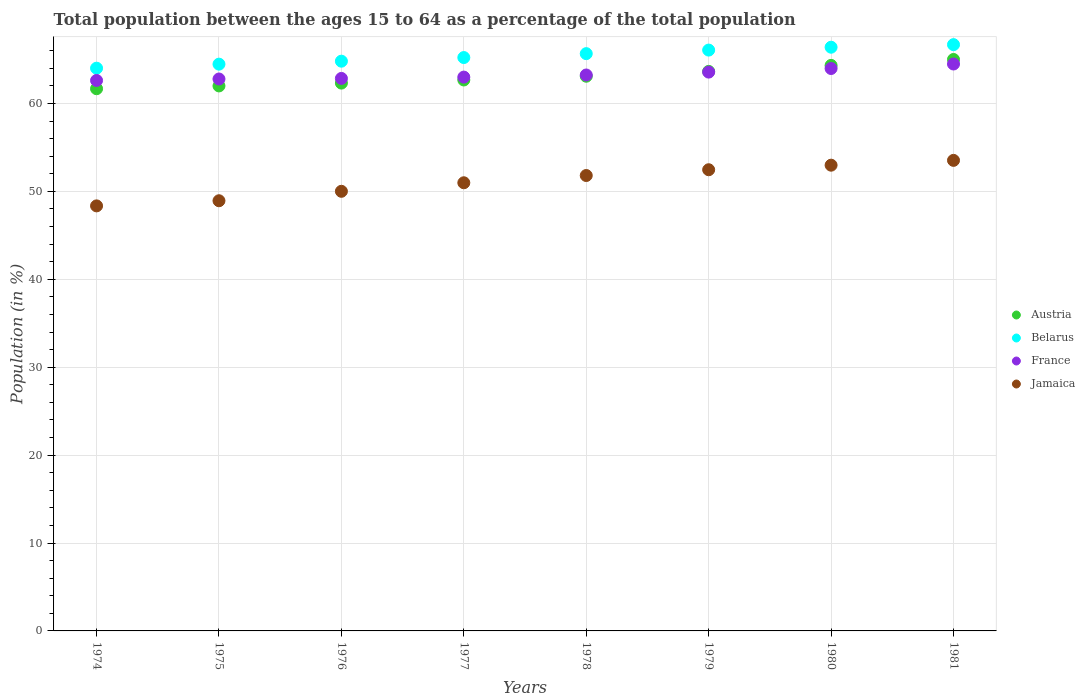How many different coloured dotlines are there?
Provide a short and direct response. 4. What is the percentage of the population ages 15 to 64 in France in 1981?
Ensure brevity in your answer.  64.49. Across all years, what is the maximum percentage of the population ages 15 to 64 in Jamaica?
Offer a very short reply. 53.53. Across all years, what is the minimum percentage of the population ages 15 to 64 in Austria?
Offer a terse response. 61.68. In which year was the percentage of the population ages 15 to 64 in Belarus minimum?
Provide a succinct answer. 1974. What is the total percentage of the population ages 15 to 64 in Jamaica in the graph?
Your response must be concise. 409.06. What is the difference between the percentage of the population ages 15 to 64 in Austria in 1977 and that in 1981?
Provide a succinct answer. -2.33. What is the difference between the percentage of the population ages 15 to 64 in France in 1975 and the percentage of the population ages 15 to 64 in Belarus in 1977?
Ensure brevity in your answer.  -2.44. What is the average percentage of the population ages 15 to 64 in France per year?
Make the answer very short. 63.32. In the year 1977, what is the difference between the percentage of the population ages 15 to 64 in Belarus and percentage of the population ages 15 to 64 in Austria?
Offer a very short reply. 2.55. In how many years, is the percentage of the population ages 15 to 64 in France greater than 8?
Keep it short and to the point. 8. What is the ratio of the percentage of the population ages 15 to 64 in France in 1976 to that in 1979?
Make the answer very short. 0.99. What is the difference between the highest and the second highest percentage of the population ages 15 to 64 in Jamaica?
Offer a terse response. 0.55. What is the difference between the highest and the lowest percentage of the population ages 15 to 64 in Austria?
Offer a terse response. 3.33. Is the sum of the percentage of the population ages 15 to 64 in Belarus in 1979 and 1981 greater than the maximum percentage of the population ages 15 to 64 in Austria across all years?
Provide a succinct answer. Yes. Is it the case that in every year, the sum of the percentage of the population ages 15 to 64 in Jamaica and percentage of the population ages 15 to 64 in France  is greater than the sum of percentage of the population ages 15 to 64 in Belarus and percentage of the population ages 15 to 64 in Austria?
Offer a terse response. No. Is the percentage of the population ages 15 to 64 in Jamaica strictly less than the percentage of the population ages 15 to 64 in Austria over the years?
Make the answer very short. Yes. How many dotlines are there?
Your answer should be very brief. 4. How many years are there in the graph?
Give a very brief answer. 8. What is the difference between two consecutive major ticks on the Y-axis?
Give a very brief answer. 10. Does the graph contain any zero values?
Your answer should be very brief. No. Does the graph contain grids?
Provide a succinct answer. Yes. Where does the legend appear in the graph?
Your response must be concise. Center right. What is the title of the graph?
Ensure brevity in your answer.  Total population between the ages 15 to 64 as a percentage of the total population. Does "Azerbaijan" appear as one of the legend labels in the graph?
Your answer should be very brief. No. What is the Population (in %) of Austria in 1974?
Offer a terse response. 61.68. What is the Population (in %) of Belarus in 1974?
Make the answer very short. 64.01. What is the Population (in %) of France in 1974?
Provide a short and direct response. 62.62. What is the Population (in %) of Jamaica in 1974?
Keep it short and to the point. 48.35. What is the Population (in %) of Austria in 1975?
Your response must be concise. 62. What is the Population (in %) of Belarus in 1975?
Your answer should be compact. 64.47. What is the Population (in %) of France in 1975?
Provide a short and direct response. 62.79. What is the Population (in %) of Jamaica in 1975?
Make the answer very short. 48.94. What is the Population (in %) in Austria in 1976?
Your answer should be very brief. 62.32. What is the Population (in %) of Belarus in 1976?
Offer a very short reply. 64.81. What is the Population (in %) of France in 1976?
Ensure brevity in your answer.  62.85. What is the Population (in %) in Jamaica in 1976?
Your response must be concise. 50.01. What is the Population (in %) of Austria in 1977?
Keep it short and to the point. 62.67. What is the Population (in %) in Belarus in 1977?
Keep it short and to the point. 65.23. What is the Population (in %) of France in 1977?
Provide a short and direct response. 63. What is the Population (in %) in Jamaica in 1977?
Ensure brevity in your answer.  50.98. What is the Population (in %) in Austria in 1978?
Offer a very short reply. 63.1. What is the Population (in %) of Belarus in 1978?
Your answer should be compact. 65.67. What is the Population (in %) in France in 1978?
Offer a terse response. 63.24. What is the Population (in %) in Jamaica in 1978?
Ensure brevity in your answer.  51.81. What is the Population (in %) in Austria in 1979?
Provide a short and direct response. 63.65. What is the Population (in %) in Belarus in 1979?
Offer a terse response. 66.07. What is the Population (in %) of France in 1979?
Offer a very short reply. 63.57. What is the Population (in %) in Jamaica in 1979?
Make the answer very short. 52.46. What is the Population (in %) of Austria in 1980?
Your answer should be very brief. 64.33. What is the Population (in %) of Belarus in 1980?
Your answer should be very brief. 66.4. What is the Population (in %) in France in 1980?
Ensure brevity in your answer.  63.98. What is the Population (in %) of Jamaica in 1980?
Make the answer very short. 52.98. What is the Population (in %) of Austria in 1981?
Keep it short and to the point. 65.01. What is the Population (in %) in Belarus in 1981?
Keep it short and to the point. 66.69. What is the Population (in %) in France in 1981?
Keep it short and to the point. 64.49. What is the Population (in %) in Jamaica in 1981?
Keep it short and to the point. 53.53. Across all years, what is the maximum Population (in %) of Austria?
Ensure brevity in your answer.  65.01. Across all years, what is the maximum Population (in %) of Belarus?
Your answer should be very brief. 66.69. Across all years, what is the maximum Population (in %) of France?
Offer a terse response. 64.49. Across all years, what is the maximum Population (in %) in Jamaica?
Provide a succinct answer. 53.53. Across all years, what is the minimum Population (in %) in Austria?
Ensure brevity in your answer.  61.68. Across all years, what is the minimum Population (in %) of Belarus?
Keep it short and to the point. 64.01. Across all years, what is the minimum Population (in %) of France?
Your answer should be compact. 62.62. Across all years, what is the minimum Population (in %) of Jamaica?
Make the answer very short. 48.35. What is the total Population (in %) of Austria in the graph?
Provide a short and direct response. 504.76. What is the total Population (in %) of Belarus in the graph?
Provide a short and direct response. 523.36. What is the total Population (in %) in France in the graph?
Give a very brief answer. 506.54. What is the total Population (in %) of Jamaica in the graph?
Your response must be concise. 409.06. What is the difference between the Population (in %) of Austria in 1974 and that in 1975?
Ensure brevity in your answer.  -0.32. What is the difference between the Population (in %) in Belarus in 1974 and that in 1975?
Offer a very short reply. -0.46. What is the difference between the Population (in %) in France in 1974 and that in 1975?
Offer a very short reply. -0.17. What is the difference between the Population (in %) in Jamaica in 1974 and that in 1975?
Offer a terse response. -0.58. What is the difference between the Population (in %) in Austria in 1974 and that in 1976?
Provide a succinct answer. -0.64. What is the difference between the Population (in %) of Belarus in 1974 and that in 1976?
Provide a short and direct response. -0.8. What is the difference between the Population (in %) of France in 1974 and that in 1976?
Give a very brief answer. -0.23. What is the difference between the Population (in %) in Jamaica in 1974 and that in 1976?
Your response must be concise. -1.66. What is the difference between the Population (in %) of Austria in 1974 and that in 1977?
Give a very brief answer. -0.99. What is the difference between the Population (in %) of Belarus in 1974 and that in 1977?
Make the answer very short. -1.21. What is the difference between the Population (in %) of France in 1974 and that in 1977?
Make the answer very short. -0.38. What is the difference between the Population (in %) in Jamaica in 1974 and that in 1977?
Provide a succinct answer. -2.63. What is the difference between the Population (in %) of Austria in 1974 and that in 1978?
Offer a very short reply. -1.42. What is the difference between the Population (in %) in Belarus in 1974 and that in 1978?
Offer a terse response. -1.66. What is the difference between the Population (in %) of France in 1974 and that in 1978?
Offer a very short reply. -0.62. What is the difference between the Population (in %) in Jamaica in 1974 and that in 1978?
Make the answer very short. -3.45. What is the difference between the Population (in %) of Austria in 1974 and that in 1979?
Give a very brief answer. -1.97. What is the difference between the Population (in %) in Belarus in 1974 and that in 1979?
Provide a succinct answer. -2.06. What is the difference between the Population (in %) in France in 1974 and that in 1979?
Give a very brief answer. -0.95. What is the difference between the Population (in %) of Jamaica in 1974 and that in 1979?
Give a very brief answer. -4.11. What is the difference between the Population (in %) in Austria in 1974 and that in 1980?
Make the answer very short. -2.65. What is the difference between the Population (in %) in Belarus in 1974 and that in 1980?
Offer a very short reply. -2.39. What is the difference between the Population (in %) of France in 1974 and that in 1980?
Provide a short and direct response. -1.36. What is the difference between the Population (in %) in Jamaica in 1974 and that in 1980?
Your response must be concise. -4.63. What is the difference between the Population (in %) of Austria in 1974 and that in 1981?
Offer a very short reply. -3.33. What is the difference between the Population (in %) in Belarus in 1974 and that in 1981?
Ensure brevity in your answer.  -2.68. What is the difference between the Population (in %) of France in 1974 and that in 1981?
Your response must be concise. -1.87. What is the difference between the Population (in %) of Jamaica in 1974 and that in 1981?
Your response must be concise. -5.18. What is the difference between the Population (in %) of Austria in 1975 and that in 1976?
Your response must be concise. -0.32. What is the difference between the Population (in %) of Belarus in 1975 and that in 1976?
Provide a succinct answer. -0.34. What is the difference between the Population (in %) of France in 1975 and that in 1976?
Your answer should be compact. -0.07. What is the difference between the Population (in %) in Jamaica in 1975 and that in 1976?
Your answer should be compact. -1.07. What is the difference between the Population (in %) in Austria in 1975 and that in 1977?
Provide a succinct answer. -0.68. What is the difference between the Population (in %) of Belarus in 1975 and that in 1977?
Ensure brevity in your answer.  -0.75. What is the difference between the Population (in %) in France in 1975 and that in 1977?
Make the answer very short. -0.21. What is the difference between the Population (in %) in Jamaica in 1975 and that in 1977?
Provide a succinct answer. -2.05. What is the difference between the Population (in %) in Austria in 1975 and that in 1978?
Provide a short and direct response. -1.1. What is the difference between the Population (in %) of Belarus in 1975 and that in 1978?
Offer a very short reply. -1.2. What is the difference between the Population (in %) in France in 1975 and that in 1978?
Provide a succinct answer. -0.46. What is the difference between the Population (in %) in Jamaica in 1975 and that in 1978?
Ensure brevity in your answer.  -2.87. What is the difference between the Population (in %) of Austria in 1975 and that in 1979?
Make the answer very short. -1.65. What is the difference between the Population (in %) in Belarus in 1975 and that in 1979?
Your answer should be compact. -1.6. What is the difference between the Population (in %) in France in 1975 and that in 1979?
Your answer should be very brief. -0.78. What is the difference between the Population (in %) in Jamaica in 1975 and that in 1979?
Offer a terse response. -3.53. What is the difference between the Population (in %) in Austria in 1975 and that in 1980?
Provide a short and direct response. -2.33. What is the difference between the Population (in %) of Belarus in 1975 and that in 1980?
Offer a terse response. -1.93. What is the difference between the Population (in %) in France in 1975 and that in 1980?
Provide a short and direct response. -1.19. What is the difference between the Population (in %) of Jamaica in 1975 and that in 1980?
Offer a very short reply. -4.05. What is the difference between the Population (in %) of Austria in 1975 and that in 1981?
Provide a short and direct response. -3.01. What is the difference between the Population (in %) of Belarus in 1975 and that in 1981?
Keep it short and to the point. -2.22. What is the difference between the Population (in %) in France in 1975 and that in 1981?
Your answer should be very brief. -1.7. What is the difference between the Population (in %) in Jamaica in 1975 and that in 1981?
Offer a terse response. -4.59. What is the difference between the Population (in %) of Austria in 1976 and that in 1977?
Offer a terse response. -0.35. What is the difference between the Population (in %) of Belarus in 1976 and that in 1977?
Make the answer very short. -0.41. What is the difference between the Population (in %) of France in 1976 and that in 1977?
Give a very brief answer. -0.15. What is the difference between the Population (in %) of Jamaica in 1976 and that in 1977?
Keep it short and to the point. -0.97. What is the difference between the Population (in %) in Austria in 1976 and that in 1978?
Keep it short and to the point. -0.78. What is the difference between the Population (in %) in Belarus in 1976 and that in 1978?
Give a very brief answer. -0.86. What is the difference between the Population (in %) in France in 1976 and that in 1978?
Offer a terse response. -0.39. What is the difference between the Population (in %) of Jamaica in 1976 and that in 1978?
Offer a terse response. -1.8. What is the difference between the Population (in %) in Austria in 1976 and that in 1979?
Your answer should be compact. -1.33. What is the difference between the Population (in %) in Belarus in 1976 and that in 1979?
Ensure brevity in your answer.  -1.26. What is the difference between the Population (in %) of France in 1976 and that in 1979?
Keep it short and to the point. -0.72. What is the difference between the Population (in %) of Jamaica in 1976 and that in 1979?
Your answer should be compact. -2.45. What is the difference between the Population (in %) in Austria in 1976 and that in 1980?
Offer a terse response. -2.01. What is the difference between the Population (in %) of Belarus in 1976 and that in 1980?
Provide a succinct answer. -1.59. What is the difference between the Population (in %) in France in 1976 and that in 1980?
Keep it short and to the point. -1.13. What is the difference between the Population (in %) in Jamaica in 1976 and that in 1980?
Your answer should be compact. -2.97. What is the difference between the Population (in %) of Austria in 1976 and that in 1981?
Make the answer very short. -2.69. What is the difference between the Population (in %) in Belarus in 1976 and that in 1981?
Offer a terse response. -1.88. What is the difference between the Population (in %) in France in 1976 and that in 1981?
Provide a short and direct response. -1.64. What is the difference between the Population (in %) of Jamaica in 1976 and that in 1981?
Your answer should be very brief. -3.52. What is the difference between the Population (in %) of Austria in 1977 and that in 1978?
Provide a succinct answer. -0.43. What is the difference between the Population (in %) in Belarus in 1977 and that in 1978?
Your answer should be compact. -0.44. What is the difference between the Population (in %) in France in 1977 and that in 1978?
Ensure brevity in your answer.  -0.24. What is the difference between the Population (in %) of Jamaica in 1977 and that in 1978?
Make the answer very short. -0.82. What is the difference between the Population (in %) of Austria in 1977 and that in 1979?
Offer a terse response. -0.98. What is the difference between the Population (in %) in Belarus in 1977 and that in 1979?
Provide a short and direct response. -0.85. What is the difference between the Population (in %) in France in 1977 and that in 1979?
Offer a very short reply. -0.57. What is the difference between the Population (in %) of Jamaica in 1977 and that in 1979?
Offer a terse response. -1.48. What is the difference between the Population (in %) of Austria in 1977 and that in 1980?
Provide a short and direct response. -1.66. What is the difference between the Population (in %) in Belarus in 1977 and that in 1980?
Your response must be concise. -1.17. What is the difference between the Population (in %) in France in 1977 and that in 1980?
Offer a very short reply. -0.98. What is the difference between the Population (in %) of Jamaica in 1977 and that in 1980?
Ensure brevity in your answer.  -2. What is the difference between the Population (in %) of Austria in 1977 and that in 1981?
Provide a short and direct response. -2.33. What is the difference between the Population (in %) in Belarus in 1977 and that in 1981?
Make the answer very short. -1.47. What is the difference between the Population (in %) of France in 1977 and that in 1981?
Provide a succinct answer. -1.49. What is the difference between the Population (in %) of Jamaica in 1977 and that in 1981?
Provide a short and direct response. -2.55. What is the difference between the Population (in %) of Austria in 1978 and that in 1979?
Your answer should be compact. -0.55. What is the difference between the Population (in %) of Belarus in 1978 and that in 1979?
Your answer should be compact. -0.4. What is the difference between the Population (in %) of France in 1978 and that in 1979?
Offer a very short reply. -0.33. What is the difference between the Population (in %) in Jamaica in 1978 and that in 1979?
Your answer should be compact. -0.66. What is the difference between the Population (in %) in Austria in 1978 and that in 1980?
Keep it short and to the point. -1.23. What is the difference between the Population (in %) in Belarus in 1978 and that in 1980?
Offer a very short reply. -0.73. What is the difference between the Population (in %) in France in 1978 and that in 1980?
Provide a succinct answer. -0.74. What is the difference between the Population (in %) in Jamaica in 1978 and that in 1980?
Give a very brief answer. -1.18. What is the difference between the Population (in %) in Austria in 1978 and that in 1981?
Give a very brief answer. -1.91. What is the difference between the Population (in %) of Belarus in 1978 and that in 1981?
Make the answer very short. -1.02. What is the difference between the Population (in %) of France in 1978 and that in 1981?
Provide a succinct answer. -1.25. What is the difference between the Population (in %) in Jamaica in 1978 and that in 1981?
Your response must be concise. -1.72. What is the difference between the Population (in %) in Austria in 1979 and that in 1980?
Your answer should be compact. -0.68. What is the difference between the Population (in %) of Belarus in 1979 and that in 1980?
Provide a succinct answer. -0.33. What is the difference between the Population (in %) in France in 1979 and that in 1980?
Ensure brevity in your answer.  -0.41. What is the difference between the Population (in %) in Jamaica in 1979 and that in 1980?
Your response must be concise. -0.52. What is the difference between the Population (in %) in Austria in 1979 and that in 1981?
Your answer should be very brief. -1.36. What is the difference between the Population (in %) of Belarus in 1979 and that in 1981?
Keep it short and to the point. -0.62. What is the difference between the Population (in %) of France in 1979 and that in 1981?
Provide a succinct answer. -0.92. What is the difference between the Population (in %) in Jamaica in 1979 and that in 1981?
Ensure brevity in your answer.  -1.07. What is the difference between the Population (in %) of Austria in 1980 and that in 1981?
Your answer should be very brief. -0.67. What is the difference between the Population (in %) in Belarus in 1980 and that in 1981?
Offer a terse response. -0.29. What is the difference between the Population (in %) in France in 1980 and that in 1981?
Provide a short and direct response. -0.51. What is the difference between the Population (in %) of Jamaica in 1980 and that in 1981?
Ensure brevity in your answer.  -0.55. What is the difference between the Population (in %) of Austria in 1974 and the Population (in %) of Belarus in 1975?
Make the answer very short. -2.79. What is the difference between the Population (in %) in Austria in 1974 and the Population (in %) in France in 1975?
Offer a terse response. -1.11. What is the difference between the Population (in %) in Austria in 1974 and the Population (in %) in Jamaica in 1975?
Ensure brevity in your answer.  12.74. What is the difference between the Population (in %) of Belarus in 1974 and the Population (in %) of France in 1975?
Provide a short and direct response. 1.23. What is the difference between the Population (in %) of Belarus in 1974 and the Population (in %) of Jamaica in 1975?
Make the answer very short. 15.08. What is the difference between the Population (in %) of France in 1974 and the Population (in %) of Jamaica in 1975?
Your answer should be very brief. 13.68. What is the difference between the Population (in %) of Austria in 1974 and the Population (in %) of Belarus in 1976?
Offer a very short reply. -3.13. What is the difference between the Population (in %) in Austria in 1974 and the Population (in %) in France in 1976?
Give a very brief answer. -1.17. What is the difference between the Population (in %) in Austria in 1974 and the Population (in %) in Jamaica in 1976?
Your response must be concise. 11.67. What is the difference between the Population (in %) in Belarus in 1974 and the Population (in %) in France in 1976?
Make the answer very short. 1.16. What is the difference between the Population (in %) of Belarus in 1974 and the Population (in %) of Jamaica in 1976?
Provide a succinct answer. 14. What is the difference between the Population (in %) of France in 1974 and the Population (in %) of Jamaica in 1976?
Give a very brief answer. 12.61. What is the difference between the Population (in %) in Austria in 1974 and the Population (in %) in Belarus in 1977?
Your answer should be very brief. -3.55. What is the difference between the Population (in %) of Austria in 1974 and the Population (in %) of France in 1977?
Give a very brief answer. -1.32. What is the difference between the Population (in %) of Austria in 1974 and the Population (in %) of Jamaica in 1977?
Offer a very short reply. 10.7. What is the difference between the Population (in %) in Belarus in 1974 and the Population (in %) in France in 1977?
Your answer should be very brief. 1.01. What is the difference between the Population (in %) of Belarus in 1974 and the Population (in %) of Jamaica in 1977?
Provide a short and direct response. 13.03. What is the difference between the Population (in %) of France in 1974 and the Population (in %) of Jamaica in 1977?
Give a very brief answer. 11.64. What is the difference between the Population (in %) of Austria in 1974 and the Population (in %) of Belarus in 1978?
Give a very brief answer. -3.99. What is the difference between the Population (in %) in Austria in 1974 and the Population (in %) in France in 1978?
Offer a very short reply. -1.56. What is the difference between the Population (in %) of Austria in 1974 and the Population (in %) of Jamaica in 1978?
Provide a short and direct response. 9.87. What is the difference between the Population (in %) of Belarus in 1974 and the Population (in %) of France in 1978?
Your answer should be very brief. 0.77. What is the difference between the Population (in %) of Belarus in 1974 and the Population (in %) of Jamaica in 1978?
Provide a short and direct response. 12.21. What is the difference between the Population (in %) of France in 1974 and the Population (in %) of Jamaica in 1978?
Your answer should be compact. 10.81. What is the difference between the Population (in %) of Austria in 1974 and the Population (in %) of Belarus in 1979?
Offer a very short reply. -4.4. What is the difference between the Population (in %) of Austria in 1974 and the Population (in %) of France in 1979?
Your answer should be very brief. -1.89. What is the difference between the Population (in %) in Austria in 1974 and the Population (in %) in Jamaica in 1979?
Your response must be concise. 9.22. What is the difference between the Population (in %) of Belarus in 1974 and the Population (in %) of France in 1979?
Provide a short and direct response. 0.45. What is the difference between the Population (in %) in Belarus in 1974 and the Population (in %) in Jamaica in 1979?
Give a very brief answer. 11.55. What is the difference between the Population (in %) in France in 1974 and the Population (in %) in Jamaica in 1979?
Provide a short and direct response. 10.16. What is the difference between the Population (in %) in Austria in 1974 and the Population (in %) in Belarus in 1980?
Your answer should be very brief. -4.72. What is the difference between the Population (in %) of Austria in 1974 and the Population (in %) of France in 1980?
Ensure brevity in your answer.  -2.3. What is the difference between the Population (in %) in Austria in 1974 and the Population (in %) in Jamaica in 1980?
Ensure brevity in your answer.  8.7. What is the difference between the Population (in %) in Belarus in 1974 and the Population (in %) in France in 1980?
Give a very brief answer. 0.04. What is the difference between the Population (in %) in Belarus in 1974 and the Population (in %) in Jamaica in 1980?
Offer a very short reply. 11.03. What is the difference between the Population (in %) of France in 1974 and the Population (in %) of Jamaica in 1980?
Provide a short and direct response. 9.64. What is the difference between the Population (in %) of Austria in 1974 and the Population (in %) of Belarus in 1981?
Your response must be concise. -5.02. What is the difference between the Population (in %) in Austria in 1974 and the Population (in %) in France in 1981?
Give a very brief answer. -2.81. What is the difference between the Population (in %) of Austria in 1974 and the Population (in %) of Jamaica in 1981?
Keep it short and to the point. 8.15. What is the difference between the Population (in %) of Belarus in 1974 and the Population (in %) of France in 1981?
Your answer should be very brief. -0.48. What is the difference between the Population (in %) in Belarus in 1974 and the Population (in %) in Jamaica in 1981?
Your answer should be compact. 10.49. What is the difference between the Population (in %) in France in 1974 and the Population (in %) in Jamaica in 1981?
Keep it short and to the point. 9.09. What is the difference between the Population (in %) of Austria in 1975 and the Population (in %) of Belarus in 1976?
Make the answer very short. -2.81. What is the difference between the Population (in %) of Austria in 1975 and the Population (in %) of France in 1976?
Give a very brief answer. -0.85. What is the difference between the Population (in %) in Austria in 1975 and the Population (in %) in Jamaica in 1976?
Keep it short and to the point. 11.99. What is the difference between the Population (in %) of Belarus in 1975 and the Population (in %) of France in 1976?
Your response must be concise. 1.62. What is the difference between the Population (in %) in Belarus in 1975 and the Population (in %) in Jamaica in 1976?
Ensure brevity in your answer.  14.46. What is the difference between the Population (in %) of France in 1975 and the Population (in %) of Jamaica in 1976?
Your answer should be very brief. 12.78. What is the difference between the Population (in %) in Austria in 1975 and the Population (in %) in Belarus in 1977?
Your response must be concise. -3.23. What is the difference between the Population (in %) of Austria in 1975 and the Population (in %) of France in 1977?
Offer a terse response. -1. What is the difference between the Population (in %) of Austria in 1975 and the Population (in %) of Jamaica in 1977?
Offer a very short reply. 11.02. What is the difference between the Population (in %) in Belarus in 1975 and the Population (in %) in France in 1977?
Offer a very short reply. 1.47. What is the difference between the Population (in %) in Belarus in 1975 and the Population (in %) in Jamaica in 1977?
Provide a succinct answer. 13.49. What is the difference between the Population (in %) of France in 1975 and the Population (in %) of Jamaica in 1977?
Your answer should be very brief. 11.81. What is the difference between the Population (in %) of Austria in 1975 and the Population (in %) of Belarus in 1978?
Give a very brief answer. -3.67. What is the difference between the Population (in %) of Austria in 1975 and the Population (in %) of France in 1978?
Offer a terse response. -1.24. What is the difference between the Population (in %) in Austria in 1975 and the Population (in %) in Jamaica in 1978?
Give a very brief answer. 10.19. What is the difference between the Population (in %) of Belarus in 1975 and the Population (in %) of France in 1978?
Provide a short and direct response. 1.23. What is the difference between the Population (in %) in Belarus in 1975 and the Population (in %) in Jamaica in 1978?
Your answer should be compact. 12.67. What is the difference between the Population (in %) of France in 1975 and the Population (in %) of Jamaica in 1978?
Give a very brief answer. 10.98. What is the difference between the Population (in %) in Austria in 1975 and the Population (in %) in Belarus in 1979?
Offer a very short reply. -4.08. What is the difference between the Population (in %) in Austria in 1975 and the Population (in %) in France in 1979?
Offer a very short reply. -1.57. What is the difference between the Population (in %) of Austria in 1975 and the Population (in %) of Jamaica in 1979?
Keep it short and to the point. 9.53. What is the difference between the Population (in %) in Belarus in 1975 and the Population (in %) in France in 1979?
Offer a terse response. 0.9. What is the difference between the Population (in %) in Belarus in 1975 and the Population (in %) in Jamaica in 1979?
Keep it short and to the point. 12.01. What is the difference between the Population (in %) of France in 1975 and the Population (in %) of Jamaica in 1979?
Give a very brief answer. 10.32. What is the difference between the Population (in %) of Austria in 1975 and the Population (in %) of Belarus in 1980?
Ensure brevity in your answer.  -4.4. What is the difference between the Population (in %) of Austria in 1975 and the Population (in %) of France in 1980?
Ensure brevity in your answer.  -1.98. What is the difference between the Population (in %) of Austria in 1975 and the Population (in %) of Jamaica in 1980?
Keep it short and to the point. 9.02. What is the difference between the Population (in %) in Belarus in 1975 and the Population (in %) in France in 1980?
Your answer should be compact. 0.5. What is the difference between the Population (in %) in Belarus in 1975 and the Population (in %) in Jamaica in 1980?
Make the answer very short. 11.49. What is the difference between the Population (in %) in France in 1975 and the Population (in %) in Jamaica in 1980?
Provide a succinct answer. 9.8. What is the difference between the Population (in %) in Austria in 1975 and the Population (in %) in Belarus in 1981?
Keep it short and to the point. -4.7. What is the difference between the Population (in %) of Austria in 1975 and the Population (in %) of France in 1981?
Provide a short and direct response. -2.49. What is the difference between the Population (in %) in Austria in 1975 and the Population (in %) in Jamaica in 1981?
Your answer should be compact. 8.47. What is the difference between the Population (in %) in Belarus in 1975 and the Population (in %) in France in 1981?
Give a very brief answer. -0.02. What is the difference between the Population (in %) in Belarus in 1975 and the Population (in %) in Jamaica in 1981?
Offer a terse response. 10.95. What is the difference between the Population (in %) in France in 1975 and the Population (in %) in Jamaica in 1981?
Your answer should be very brief. 9.26. What is the difference between the Population (in %) of Austria in 1976 and the Population (in %) of Belarus in 1977?
Keep it short and to the point. -2.91. What is the difference between the Population (in %) of Austria in 1976 and the Population (in %) of France in 1977?
Offer a terse response. -0.68. What is the difference between the Population (in %) in Austria in 1976 and the Population (in %) in Jamaica in 1977?
Your answer should be compact. 11.34. What is the difference between the Population (in %) of Belarus in 1976 and the Population (in %) of France in 1977?
Your response must be concise. 1.81. What is the difference between the Population (in %) of Belarus in 1976 and the Population (in %) of Jamaica in 1977?
Make the answer very short. 13.83. What is the difference between the Population (in %) of France in 1976 and the Population (in %) of Jamaica in 1977?
Give a very brief answer. 11.87. What is the difference between the Population (in %) of Austria in 1976 and the Population (in %) of Belarus in 1978?
Give a very brief answer. -3.35. What is the difference between the Population (in %) in Austria in 1976 and the Population (in %) in France in 1978?
Your answer should be very brief. -0.92. What is the difference between the Population (in %) of Austria in 1976 and the Population (in %) of Jamaica in 1978?
Provide a short and direct response. 10.51. What is the difference between the Population (in %) in Belarus in 1976 and the Population (in %) in France in 1978?
Provide a short and direct response. 1.57. What is the difference between the Population (in %) of Belarus in 1976 and the Population (in %) of Jamaica in 1978?
Give a very brief answer. 13.01. What is the difference between the Population (in %) in France in 1976 and the Population (in %) in Jamaica in 1978?
Make the answer very short. 11.05. What is the difference between the Population (in %) of Austria in 1976 and the Population (in %) of Belarus in 1979?
Provide a short and direct response. -3.76. What is the difference between the Population (in %) in Austria in 1976 and the Population (in %) in France in 1979?
Make the answer very short. -1.25. What is the difference between the Population (in %) in Austria in 1976 and the Population (in %) in Jamaica in 1979?
Give a very brief answer. 9.86. What is the difference between the Population (in %) of Belarus in 1976 and the Population (in %) of France in 1979?
Provide a succinct answer. 1.24. What is the difference between the Population (in %) of Belarus in 1976 and the Population (in %) of Jamaica in 1979?
Offer a very short reply. 12.35. What is the difference between the Population (in %) of France in 1976 and the Population (in %) of Jamaica in 1979?
Give a very brief answer. 10.39. What is the difference between the Population (in %) of Austria in 1976 and the Population (in %) of Belarus in 1980?
Make the answer very short. -4.08. What is the difference between the Population (in %) in Austria in 1976 and the Population (in %) in France in 1980?
Make the answer very short. -1.66. What is the difference between the Population (in %) in Austria in 1976 and the Population (in %) in Jamaica in 1980?
Provide a short and direct response. 9.34. What is the difference between the Population (in %) of Belarus in 1976 and the Population (in %) of France in 1980?
Make the answer very short. 0.83. What is the difference between the Population (in %) in Belarus in 1976 and the Population (in %) in Jamaica in 1980?
Provide a succinct answer. 11.83. What is the difference between the Population (in %) in France in 1976 and the Population (in %) in Jamaica in 1980?
Provide a succinct answer. 9.87. What is the difference between the Population (in %) of Austria in 1976 and the Population (in %) of Belarus in 1981?
Give a very brief answer. -4.38. What is the difference between the Population (in %) of Austria in 1976 and the Population (in %) of France in 1981?
Your response must be concise. -2.17. What is the difference between the Population (in %) in Austria in 1976 and the Population (in %) in Jamaica in 1981?
Provide a succinct answer. 8.79. What is the difference between the Population (in %) in Belarus in 1976 and the Population (in %) in France in 1981?
Offer a very short reply. 0.32. What is the difference between the Population (in %) in Belarus in 1976 and the Population (in %) in Jamaica in 1981?
Ensure brevity in your answer.  11.28. What is the difference between the Population (in %) in France in 1976 and the Population (in %) in Jamaica in 1981?
Make the answer very short. 9.32. What is the difference between the Population (in %) in Austria in 1977 and the Population (in %) in Belarus in 1978?
Provide a short and direct response. -3. What is the difference between the Population (in %) of Austria in 1977 and the Population (in %) of France in 1978?
Keep it short and to the point. -0.57. What is the difference between the Population (in %) of Austria in 1977 and the Population (in %) of Jamaica in 1978?
Give a very brief answer. 10.87. What is the difference between the Population (in %) of Belarus in 1977 and the Population (in %) of France in 1978?
Keep it short and to the point. 1.98. What is the difference between the Population (in %) of Belarus in 1977 and the Population (in %) of Jamaica in 1978?
Your response must be concise. 13.42. What is the difference between the Population (in %) in France in 1977 and the Population (in %) in Jamaica in 1978?
Provide a succinct answer. 11.2. What is the difference between the Population (in %) of Austria in 1977 and the Population (in %) of Belarus in 1979?
Provide a succinct answer. -3.4. What is the difference between the Population (in %) of Austria in 1977 and the Population (in %) of France in 1979?
Give a very brief answer. -0.9. What is the difference between the Population (in %) in Austria in 1977 and the Population (in %) in Jamaica in 1979?
Provide a succinct answer. 10.21. What is the difference between the Population (in %) of Belarus in 1977 and the Population (in %) of France in 1979?
Give a very brief answer. 1.66. What is the difference between the Population (in %) of Belarus in 1977 and the Population (in %) of Jamaica in 1979?
Provide a short and direct response. 12.76. What is the difference between the Population (in %) of France in 1977 and the Population (in %) of Jamaica in 1979?
Offer a very short reply. 10.54. What is the difference between the Population (in %) of Austria in 1977 and the Population (in %) of Belarus in 1980?
Offer a terse response. -3.73. What is the difference between the Population (in %) of Austria in 1977 and the Population (in %) of France in 1980?
Provide a succinct answer. -1.31. What is the difference between the Population (in %) in Austria in 1977 and the Population (in %) in Jamaica in 1980?
Offer a terse response. 9.69. What is the difference between the Population (in %) in Belarus in 1977 and the Population (in %) in France in 1980?
Make the answer very short. 1.25. What is the difference between the Population (in %) in Belarus in 1977 and the Population (in %) in Jamaica in 1980?
Your response must be concise. 12.24. What is the difference between the Population (in %) in France in 1977 and the Population (in %) in Jamaica in 1980?
Your response must be concise. 10.02. What is the difference between the Population (in %) in Austria in 1977 and the Population (in %) in Belarus in 1981?
Make the answer very short. -4.02. What is the difference between the Population (in %) of Austria in 1977 and the Population (in %) of France in 1981?
Make the answer very short. -1.82. What is the difference between the Population (in %) in Austria in 1977 and the Population (in %) in Jamaica in 1981?
Ensure brevity in your answer.  9.14. What is the difference between the Population (in %) of Belarus in 1977 and the Population (in %) of France in 1981?
Your response must be concise. 0.74. What is the difference between the Population (in %) of Belarus in 1977 and the Population (in %) of Jamaica in 1981?
Provide a succinct answer. 11.7. What is the difference between the Population (in %) in France in 1977 and the Population (in %) in Jamaica in 1981?
Provide a succinct answer. 9.47. What is the difference between the Population (in %) in Austria in 1978 and the Population (in %) in Belarus in 1979?
Keep it short and to the point. -2.97. What is the difference between the Population (in %) in Austria in 1978 and the Population (in %) in France in 1979?
Your answer should be very brief. -0.47. What is the difference between the Population (in %) of Austria in 1978 and the Population (in %) of Jamaica in 1979?
Provide a succinct answer. 10.64. What is the difference between the Population (in %) of Belarus in 1978 and the Population (in %) of France in 1979?
Offer a very short reply. 2.1. What is the difference between the Population (in %) of Belarus in 1978 and the Population (in %) of Jamaica in 1979?
Your answer should be very brief. 13.21. What is the difference between the Population (in %) in France in 1978 and the Population (in %) in Jamaica in 1979?
Offer a very short reply. 10.78. What is the difference between the Population (in %) of Austria in 1978 and the Population (in %) of Belarus in 1980?
Make the answer very short. -3.3. What is the difference between the Population (in %) of Austria in 1978 and the Population (in %) of France in 1980?
Keep it short and to the point. -0.88. What is the difference between the Population (in %) in Austria in 1978 and the Population (in %) in Jamaica in 1980?
Your answer should be very brief. 10.12. What is the difference between the Population (in %) of Belarus in 1978 and the Population (in %) of France in 1980?
Your response must be concise. 1.69. What is the difference between the Population (in %) in Belarus in 1978 and the Population (in %) in Jamaica in 1980?
Keep it short and to the point. 12.69. What is the difference between the Population (in %) in France in 1978 and the Population (in %) in Jamaica in 1980?
Your answer should be very brief. 10.26. What is the difference between the Population (in %) of Austria in 1978 and the Population (in %) of Belarus in 1981?
Offer a very short reply. -3.59. What is the difference between the Population (in %) of Austria in 1978 and the Population (in %) of France in 1981?
Ensure brevity in your answer.  -1.39. What is the difference between the Population (in %) of Austria in 1978 and the Population (in %) of Jamaica in 1981?
Keep it short and to the point. 9.57. What is the difference between the Population (in %) of Belarus in 1978 and the Population (in %) of France in 1981?
Give a very brief answer. 1.18. What is the difference between the Population (in %) of Belarus in 1978 and the Population (in %) of Jamaica in 1981?
Offer a very short reply. 12.14. What is the difference between the Population (in %) in France in 1978 and the Population (in %) in Jamaica in 1981?
Your answer should be very brief. 9.71. What is the difference between the Population (in %) of Austria in 1979 and the Population (in %) of Belarus in 1980?
Keep it short and to the point. -2.75. What is the difference between the Population (in %) of Austria in 1979 and the Population (in %) of France in 1980?
Make the answer very short. -0.33. What is the difference between the Population (in %) in Austria in 1979 and the Population (in %) in Jamaica in 1980?
Make the answer very short. 10.67. What is the difference between the Population (in %) of Belarus in 1979 and the Population (in %) of France in 1980?
Keep it short and to the point. 2.1. What is the difference between the Population (in %) in Belarus in 1979 and the Population (in %) in Jamaica in 1980?
Your answer should be compact. 13.09. What is the difference between the Population (in %) of France in 1979 and the Population (in %) of Jamaica in 1980?
Keep it short and to the point. 10.59. What is the difference between the Population (in %) of Austria in 1979 and the Population (in %) of Belarus in 1981?
Offer a terse response. -3.04. What is the difference between the Population (in %) in Austria in 1979 and the Population (in %) in France in 1981?
Offer a terse response. -0.84. What is the difference between the Population (in %) in Austria in 1979 and the Population (in %) in Jamaica in 1981?
Offer a terse response. 10.12. What is the difference between the Population (in %) of Belarus in 1979 and the Population (in %) of France in 1981?
Offer a terse response. 1.58. What is the difference between the Population (in %) in Belarus in 1979 and the Population (in %) in Jamaica in 1981?
Offer a very short reply. 12.55. What is the difference between the Population (in %) in France in 1979 and the Population (in %) in Jamaica in 1981?
Your answer should be compact. 10.04. What is the difference between the Population (in %) of Austria in 1980 and the Population (in %) of Belarus in 1981?
Provide a succinct answer. -2.36. What is the difference between the Population (in %) in Austria in 1980 and the Population (in %) in France in 1981?
Ensure brevity in your answer.  -0.16. What is the difference between the Population (in %) of Austria in 1980 and the Population (in %) of Jamaica in 1981?
Provide a succinct answer. 10.8. What is the difference between the Population (in %) of Belarus in 1980 and the Population (in %) of France in 1981?
Give a very brief answer. 1.91. What is the difference between the Population (in %) in Belarus in 1980 and the Population (in %) in Jamaica in 1981?
Provide a succinct answer. 12.87. What is the difference between the Population (in %) of France in 1980 and the Population (in %) of Jamaica in 1981?
Provide a short and direct response. 10.45. What is the average Population (in %) of Austria per year?
Keep it short and to the point. 63.09. What is the average Population (in %) of Belarus per year?
Ensure brevity in your answer.  65.42. What is the average Population (in %) of France per year?
Provide a succinct answer. 63.32. What is the average Population (in %) in Jamaica per year?
Your answer should be compact. 51.13. In the year 1974, what is the difference between the Population (in %) of Austria and Population (in %) of Belarus?
Give a very brief answer. -2.34. In the year 1974, what is the difference between the Population (in %) in Austria and Population (in %) in France?
Provide a short and direct response. -0.94. In the year 1974, what is the difference between the Population (in %) in Austria and Population (in %) in Jamaica?
Provide a succinct answer. 13.33. In the year 1974, what is the difference between the Population (in %) of Belarus and Population (in %) of France?
Your response must be concise. 1.4. In the year 1974, what is the difference between the Population (in %) of Belarus and Population (in %) of Jamaica?
Provide a succinct answer. 15.66. In the year 1974, what is the difference between the Population (in %) in France and Population (in %) in Jamaica?
Your answer should be compact. 14.27. In the year 1975, what is the difference between the Population (in %) of Austria and Population (in %) of Belarus?
Keep it short and to the point. -2.48. In the year 1975, what is the difference between the Population (in %) in Austria and Population (in %) in France?
Your answer should be compact. -0.79. In the year 1975, what is the difference between the Population (in %) in Austria and Population (in %) in Jamaica?
Offer a very short reply. 13.06. In the year 1975, what is the difference between the Population (in %) of Belarus and Population (in %) of France?
Offer a very short reply. 1.69. In the year 1975, what is the difference between the Population (in %) of Belarus and Population (in %) of Jamaica?
Ensure brevity in your answer.  15.54. In the year 1975, what is the difference between the Population (in %) in France and Population (in %) in Jamaica?
Your response must be concise. 13.85. In the year 1976, what is the difference between the Population (in %) of Austria and Population (in %) of Belarus?
Your response must be concise. -2.49. In the year 1976, what is the difference between the Population (in %) of Austria and Population (in %) of France?
Keep it short and to the point. -0.53. In the year 1976, what is the difference between the Population (in %) of Austria and Population (in %) of Jamaica?
Provide a short and direct response. 12.31. In the year 1976, what is the difference between the Population (in %) in Belarus and Population (in %) in France?
Offer a terse response. 1.96. In the year 1976, what is the difference between the Population (in %) of Belarus and Population (in %) of Jamaica?
Your answer should be compact. 14.8. In the year 1976, what is the difference between the Population (in %) of France and Population (in %) of Jamaica?
Your answer should be very brief. 12.84. In the year 1977, what is the difference between the Population (in %) in Austria and Population (in %) in Belarus?
Provide a short and direct response. -2.55. In the year 1977, what is the difference between the Population (in %) in Austria and Population (in %) in France?
Keep it short and to the point. -0.33. In the year 1977, what is the difference between the Population (in %) of Austria and Population (in %) of Jamaica?
Provide a short and direct response. 11.69. In the year 1977, what is the difference between the Population (in %) in Belarus and Population (in %) in France?
Your answer should be compact. 2.22. In the year 1977, what is the difference between the Population (in %) in Belarus and Population (in %) in Jamaica?
Make the answer very short. 14.24. In the year 1977, what is the difference between the Population (in %) of France and Population (in %) of Jamaica?
Provide a short and direct response. 12.02. In the year 1978, what is the difference between the Population (in %) of Austria and Population (in %) of Belarus?
Keep it short and to the point. -2.57. In the year 1978, what is the difference between the Population (in %) of Austria and Population (in %) of France?
Make the answer very short. -0.14. In the year 1978, what is the difference between the Population (in %) of Austria and Population (in %) of Jamaica?
Provide a short and direct response. 11.29. In the year 1978, what is the difference between the Population (in %) of Belarus and Population (in %) of France?
Provide a short and direct response. 2.43. In the year 1978, what is the difference between the Population (in %) in Belarus and Population (in %) in Jamaica?
Your response must be concise. 13.86. In the year 1978, what is the difference between the Population (in %) of France and Population (in %) of Jamaica?
Provide a succinct answer. 11.44. In the year 1979, what is the difference between the Population (in %) in Austria and Population (in %) in Belarus?
Offer a very short reply. -2.42. In the year 1979, what is the difference between the Population (in %) of Austria and Population (in %) of France?
Keep it short and to the point. 0.08. In the year 1979, what is the difference between the Population (in %) of Austria and Population (in %) of Jamaica?
Offer a very short reply. 11.19. In the year 1979, what is the difference between the Population (in %) of Belarus and Population (in %) of France?
Give a very brief answer. 2.5. In the year 1979, what is the difference between the Population (in %) in Belarus and Population (in %) in Jamaica?
Ensure brevity in your answer.  13.61. In the year 1979, what is the difference between the Population (in %) in France and Population (in %) in Jamaica?
Your answer should be compact. 11.11. In the year 1980, what is the difference between the Population (in %) in Austria and Population (in %) in Belarus?
Your answer should be very brief. -2.07. In the year 1980, what is the difference between the Population (in %) of Austria and Population (in %) of France?
Make the answer very short. 0.35. In the year 1980, what is the difference between the Population (in %) of Austria and Population (in %) of Jamaica?
Ensure brevity in your answer.  11.35. In the year 1980, what is the difference between the Population (in %) of Belarus and Population (in %) of France?
Your answer should be very brief. 2.42. In the year 1980, what is the difference between the Population (in %) of Belarus and Population (in %) of Jamaica?
Provide a succinct answer. 13.42. In the year 1980, what is the difference between the Population (in %) of France and Population (in %) of Jamaica?
Provide a succinct answer. 11. In the year 1981, what is the difference between the Population (in %) of Austria and Population (in %) of Belarus?
Offer a terse response. -1.69. In the year 1981, what is the difference between the Population (in %) of Austria and Population (in %) of France?
Your answer should be compact. 0.52. In the year 1981, what is the difference between the Population (in %) of Austria and Population (in %) of Jamaica?
Offer a very short reply. 11.48. In the year 1981, what is the difference between the Population (in %) in Belarus and Population (in %) in France?
Provide a succinct answer. 2.2. In the year 1981, what is the difference between the Population (in %) of Belarus and Population (in %) of Jamaica?
Provide a succinct answer. 13.17. In the year 1981, what is the difference between the Population (in %) in France and Population (in %) in Jamaica?
Provide a short and direct response. 10.96. What is the ratio of the Population (in %) of Belarus in 1974 to that in 1975?
Your answer should be very brief. 0.99. What is the ratio of the Population (in %) in Austria in 1974 to that in 1976?
Provide a short and direct response. 0.99. What is the ratio of the Population (in %) of Jamaica in 1974 to that in 1976?
Your answer should be very brief. 0.97. What is the ratio of the Population (in %) of Austria in 1974 to that in 1977?
Your answer should be compact. 0.98. What is the ratio of the Population (in %) of Belarus in 1974 to that in 1977?
Your answer should be very brief. 0.98. What is the ratio of the Population (in %) in Jamaica in 1974 to that in 1977?
Ensure brevity in your answer.  0.95. What is the ratio of the Population (in %) of Austria in 1974 to that in 1978?
Ensure brevity in your answer.  0.98. What is the ratio of the Population (in %) of Belarus in 1974 to that in 1978?
Make the answer very short. 0.97. What is the ratio of the Population (in %) in France in 1974 to that in 1978?
Keep it short and to the point. 0.99. What is the ratio of the Population (in %) in Belarus in 1974 to that in 1979?
Keep it short and to the point. 0.97. What is the ratio of the Population (in %) of Jamaica in 1974 to that in 1979?
Your answer should be very brief. 0.92. What is the ratio of the Population (in %) of Austria in 1974 to that in 1980?
Give a very brief answer. 0.96. What is the ratio of the Population (in %) of Belarus in 1974 to that in 1980?
Make the answer very short. 0.96. What is the ratio of the Population (in %) in France in 1974 to that in 1980?
Your answer should be very brief. 0.98. What is the ratio of the Population (in %) in Jamaica in 1974 to that in 1980?
Your response must be concise. 0.91. What is the ratio of the Population (in %) in Austria in 1974 to that in 1981?
Your response must be concise. 0.95. What is the ratio of the Population (in %) of Belarus in 1974 to that in 1981?
Your answer should be very brief. 0.96. What is the ratio of the Population (in %) of France in 1974 to that in 1981?
Ensure brevity in your answer.  0.97. What is the ratio of the Population (in %) in Jamaica in 1974 to that in 1981?
Your answer should be very brief. 0.9. What is the ratio of the Population (in %) in Belarus in 1975 to that in 1976?
Keep it short and to the point. 0.99. What is the ratio of the Population (in %) in France in 1975 to that in 1976?
Offer a terse response. 1. What is the ratio of the Population (in %) in Jamaica in 1975 to that in 1976?
Your answer should be compact. 0.98. What is the ratio of the Population (in %) of Jamaica in 1975 to that in 1977?
Provide a succinct answer. 0.96. What is the ratio of the Population (in %) of Austria in 1975 to that in 1978?
Keep it short and to the point. 0.98. What is the ratio of the Population (in %) of Belarus in 1975 to that in 1978?
Your response must be concise. 0.98. What is the ratio of the Population (in %) of Jamaica in 1975 to that in 1978?
Provide a succinct answer. 0.94. What is the ratio of the Population (in %) in Belarus in 1975 to that in 1979?
Provide a succinct answer. 0.98. What is the ratio of the Population (in %) of France in 1975 to that in 1979?
Keep it short and to the point. 0.99. What is the ratio of the Population (in %) of Jamaica in 1975 to that in 1979?
Provide a short and direct response. 0.93. What is the ratio of the Population (in %) of Austria in 1975 to that in 1980?
Your answer should be very brief. 0.96. What is the ratio of the Population (in %) of France in 1975 to that in 1980?
Offer a terse response. 0.98. What is the ratio of the Population (in %) in Jamaica in 1975 to that in 1980?
Offer a terse response. 0.92. What is the ratio of the Population (in %) in Austria in 1975 to that in 1981?
Ensure brevity in your answer.  0.95. What is the ratio of the Population (in %) in Belarus in 1975 to that in 1981?
Your answer should be very brief. 0.97. What is the ratio of the Population (in %) of France in 1975 to that in 1981?
Give a very brief answer. 0.97. What is the ratio of the Population (in %) in Jamaica in 1975 to that in 1981?
Your response must be concise. 0.91. What is the ratio of the Population (in %) in Austria in 1976 to that in 1977?
Your answer should be compact. 0.99. What is the ratio of the Population (in %) in France in 1976 to that in 1977?
Ensure brevity in your answer.  1. What is the ratio of the Population (in %) in Jamaica in 1976 to that in 1977?
Ensure brevity in your answer.  0.98. What is the ratio of the Population (in %) of Austria in 1976 to that in 1978?
Ensure brevity in your answer.  0.99. What is the ratio of the Population (in %) of Belarus in 1976 to that in 1978?
Offer a terse response. 0.99. What is the ratio of the Population (in %) in Jamaica in 1976 to that in 1978?
Make the answer very short. 0.97. What is the ratio of the Population (in %) in Austria in 1976 to that in 1979?
Your answer should be very brief. 0.98. What is the ratio of the Population (in %) of Belarus in 1976 to that in 1979?
Keep it short and to the point. 0.98. What is the ratio of the Population (in %) of France in 1976 to that in 1979?
Offer a very short reply. 0.99. What is the ratio of the Population (in %) in Jamaica in 1976 to that in 1979?
Your answer should be very brief. 0.95. What is the ratio of the Population (in %) of Austria in 1976 to that in 1980?
Your response must be concise. 0.97. What is the ratio of the Population (in %) of Belarus in 1976 to that in 1980?
Make the answer very short. 0.98. What is the ratio of the Population (in %) in France in 1976 to that in 1980?
Make the answer very short. 0.98. What is the ratio of the Population (in %) of Jamaica in 1976 to that in 1980?
Ensure brevity in your answer.  0.94. What is the ratio of the Population (in %) in Austria in 1976 to that in 1981?
Offer a terse response. 0.96. What is the ratio of the Population (in %) in Belarus in 1976 to that in 1981?
Your answer should be very brief. 0.97. What is the ratio of the Population (in %) of France in 1976 to that in 1981?
Your answer should be very brief. 0.97. What is the ratio of the Population (in %) of Jamaica in 1976 to that in 1981?
Keep it short and to the point. 0.93. What is the ratio of the Population (in %) of Austria in 1977 to that in 1978?
Your answer should be compact. 0.99. What is the ratio of the Population (in %) in France in 1977 to that in 1978?
Provide a short and direct response. 1. What is the ratio of the Population (in %) in Jamaica in 1977 to that in 1978?
Keep it short and to the point. 0.98. What is the ratio of the Population (in %) of Austria in 1977 to that in 1979?
Your response must be concise. 0.98. What is the ratio of the Population (in %) of Belarus in 1977 to that in 1979?
Your answer should be compact. 0.99. What is the ratio of the Population (in %) of Jamaica in 1977 to that in 1979?
Your response must be concise. 0.97. What is the ratio of the Population (in %) in Austria in 1977 to that in 1980?
Your answer should be very brief. 0.97. What is the ratio of the Population (in %) of Belarus in 1977 to that in 1980?
Ensure brevity in your answer.  0.98. What is the ratio of the Population (in %) in France in 1977 to that in 1980?
Your answer should be compact. 0.98. What is the ratio of the Population (in %) in Jamaica in 1977 to that in 1980?
Offer a very short reply. 0.96. What is the ratio of the Population (in %) in Austria in 1977 to that in 1981?
Your answer should be compact. 0.96. What is the ratio of the Population (in %) of Belarus in 1977 to that in 1981?
Your answer should be compact. 0.98. What is the ratio of the Population (in %) of France in 1977 to that in 1981?
Keep it short and to the point. 0.98. What is the ratio of the Population (in %) in Jamaica in 1978 to that in 1979?
Provide a succinct answer. 0.99. What is the ratio of the Population (in %) of Austria in 1978 to that in 1980?
Provide a short and direct response. 0.98. What is the ratio of the Population (in %) of France in 1978 to that in 1980?
Make the answer very short. 0.99. What is the ratio of the Population (in %) of Jamaica in 1978 to that in 1980?
Your answer should be very brief. 0.98. What is the ratio of the Population (in %) of Austria in 1978 to that in 1981?
Offer a very short reply. 0.97. What is the ratio of the Population (in %) in Belarus in 1978 to that in 1981?
Provide a succinct answer. 0.98. What is the ratio of the Population (in %) in France in 1978 to that in 1981?
Make the answer very short. 0.98. What is the ratio of the Population (in %) in Jamaica in 1978 to that in 1981?
Your answer should be compact. 0.97. What is the ratio of the Population (in %) in Austria in 1979 to that in 1980?
Offer a very short reply. 0.99. What is the ratio of the Population (in %) in Jamaica in 1979 to that in 1980?
Your response must be concise. 0.99. What is the ratio of the Population (in %) in Austria in 1979 to that in 1981?
Ensure brevity in your answer.  0.98. What is the ratio of the Population (in %) in France in 1979 to that in 1981?
Ensure brevity in your answer.  0.99. What is the ratio of the Population (in %) in Jamaica in 1979 to that in 1981?
Offer a very short reply. 0.98. What is the ratio of the Population (in %) of Belarus in 1980 to that in 1981?
Give a very brief answer. 1. What is the ratio of the Population (in %) in France in 1980 to that in 1981?
Keep it short and to the point. 0.99. What is the ratio of the Population (in %) in Jamaica in 1980 to that in 1981?
Ensure brevity in your answer.  0.99. What is the difference between the highest and the second highest Population (in %) in Austria?
Your answer should be very brief. 0.67. What is the difference between the highest and the second highest Population (in %) of Belarus?
Provide a succinct answer. 0.29. What is the difference between the highest and the second highest Population (in %) in France?
Ensure brevity in your answer.  0.51. What is the difference between the highest and the second highest Population (in %) in Jamaica?
Make the answer very short. 0.55. What is the difference between the highest and the lowest Population (in %) in Austria?
Keep it short and to the point. 3.33. What is the difference between the highest and the lowest Population (in %) of Belarus?
Give a very brief answer. 2.68. What is the difference between the highest and the lowest Population (in %) in France?
Offer a terse response. 1.87. What is the difference between the highest and the lowest Population (in %) in Jamaica?
Your answer should be compact. 5.18. 